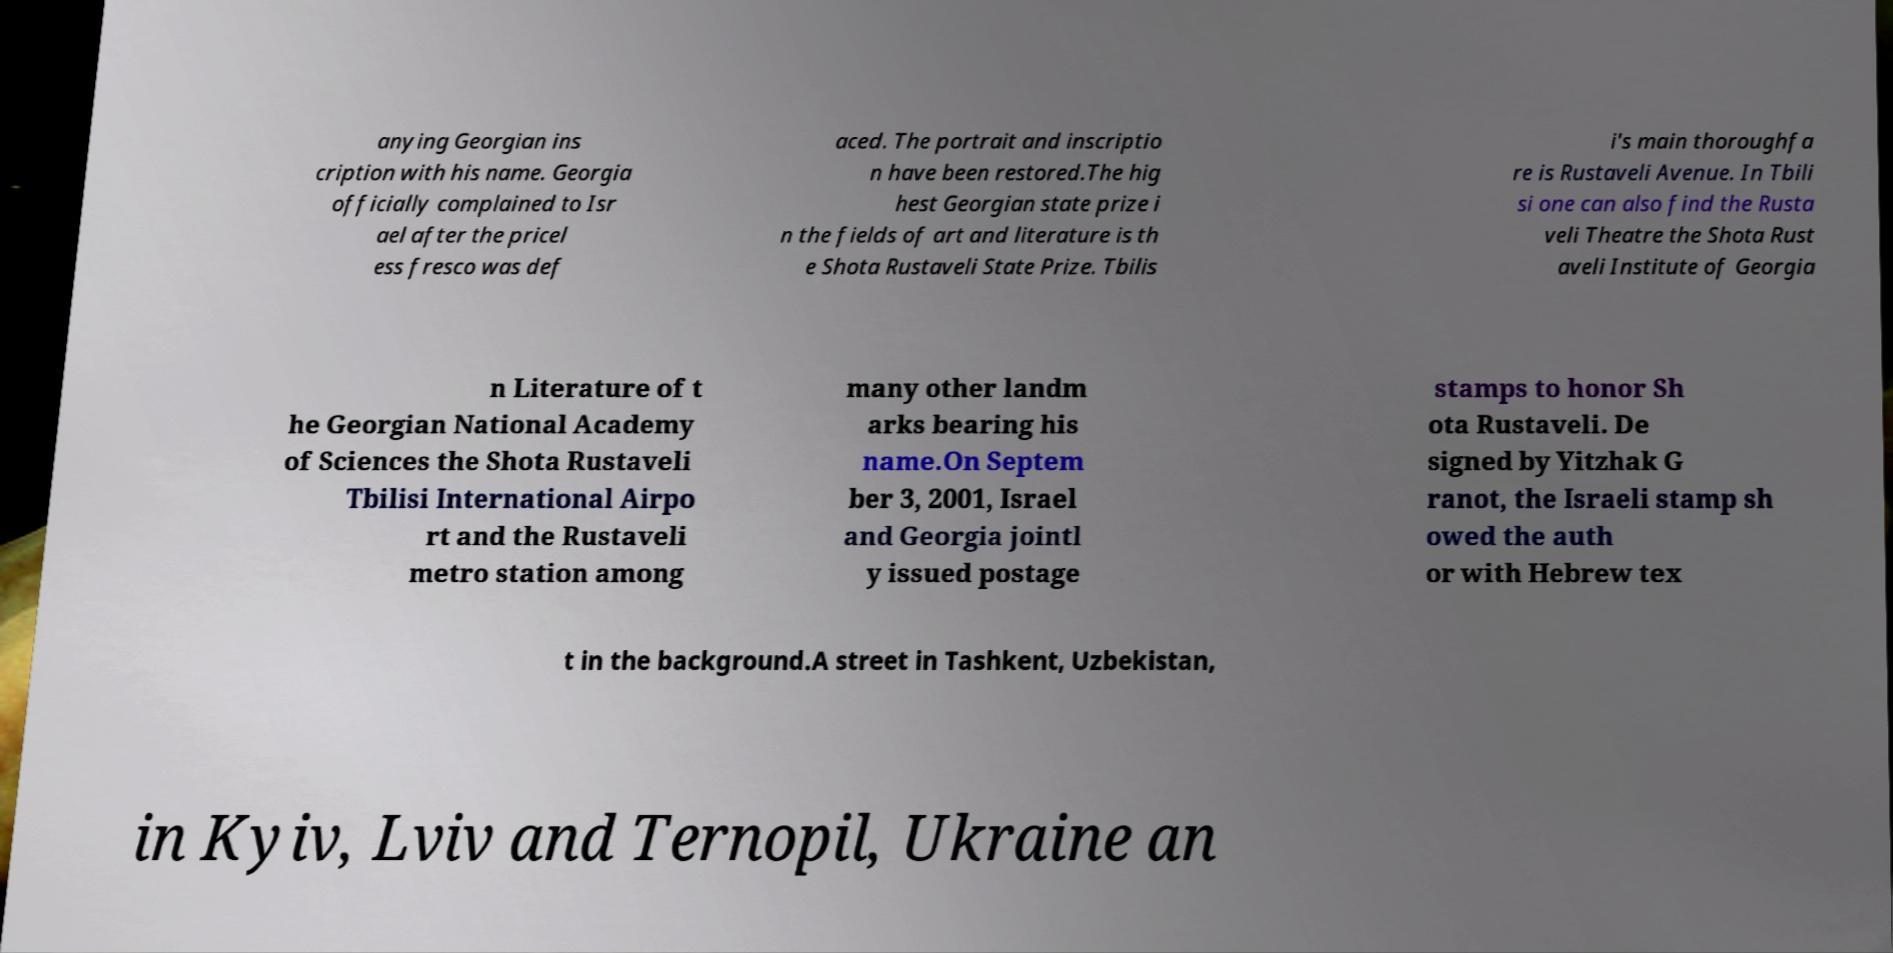I need the written content from this picture converted into text. Can you do that? anying Georgian ins cription with his name. Georgia officially complained to Isr ael after the pricel ess fresco was def aced. The portrait and inscriptio n have been restored.The hig hest Georgian state prize i n the fields of art and literature is th e Shota Rustaveli State Prize. Tbilis i's main thoroughfa re is Rustaveli Avenue. In Tbili si one can also find the Rusta veli Theatre the Shota Rust aveli Institute of Georgia n Literature of t he Georgian National Academy of Sciences the Shota Rustaveli Tbilisi International Airpo rt and the Rustaveli metro station among many other landm arks bearing his name.On Septem ber 3, 2001, Israel and Georgia jointl y issued postage stamps to honor Sh ota Rustaveli. De signed by Yitzhak G ranot, the Israeli stamp sh owed the auth or with Hebrew tex t in the background.A street in Tashkent, Uzbekistan, in Kyiv, Lviv and Ternopil, Ukraine an 